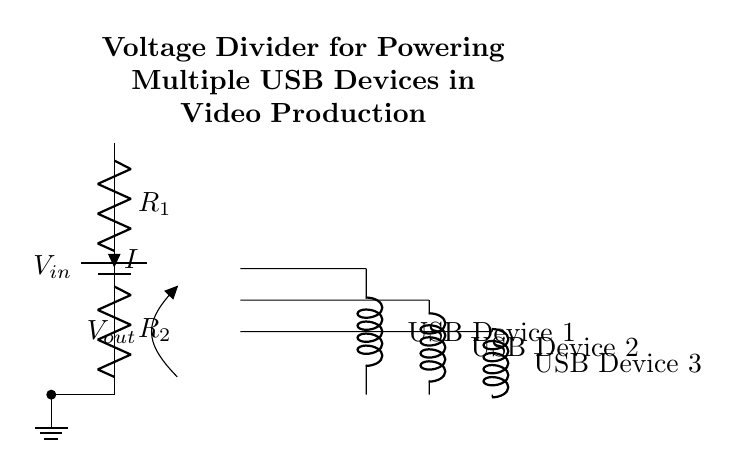What is the input voltage of the circuit? The input voltage is indicated by the label \( V_{in} \) connected to the battery symbol at the top left of the circuit diagram.
Answer: \( V_{in} \) What type of resistors are used in the voltage divider? The circuit shows two resistors labeled \( R_1 \) and \( R_2 \), which are standard resistors used for voltage division.
Answer: Resistors How many USB devices are powered by this circuit? The diagram illustrates three USB devices connected in parallel to the output section, confirming that three devices are being powered.
Answer: Three What is the relationship between \( V_{out} \) and \( V_{in} \)? The output voltage \( V_{out} \) is derived from the input voltage \( V_{in} \) based on the values of \( R_1 \) and \( R_2 \) according to the voltage divider formula, meaning \( V_{out} < V_{in} \).
Answer: Proportional What happens to the output voltage if \( R_2 \) is increased? Increasing \( R_2 \) reduces the current through the circuit, leading to a higher \( V_{out} \) from the voltage divider, since \( V_{out} \) is inversely related to \( R_2 \).
Answer: Increases What is the purpose of the voltage divider in this circuit? The voltage divider's primary purpose is to step down the higher \( V_{in} \) to a lower voltage suitable for the USB devices, providing them with the necessary power for operation.
Answer: Voltage reduction What would happen if the resistors were bypassed? Bypassing the resistors would create a short circuit, directly connecting \( V_{in} \) to the output, potentially damaging the USB devices due to excessive voltage and current.
Answer: Short circuit 